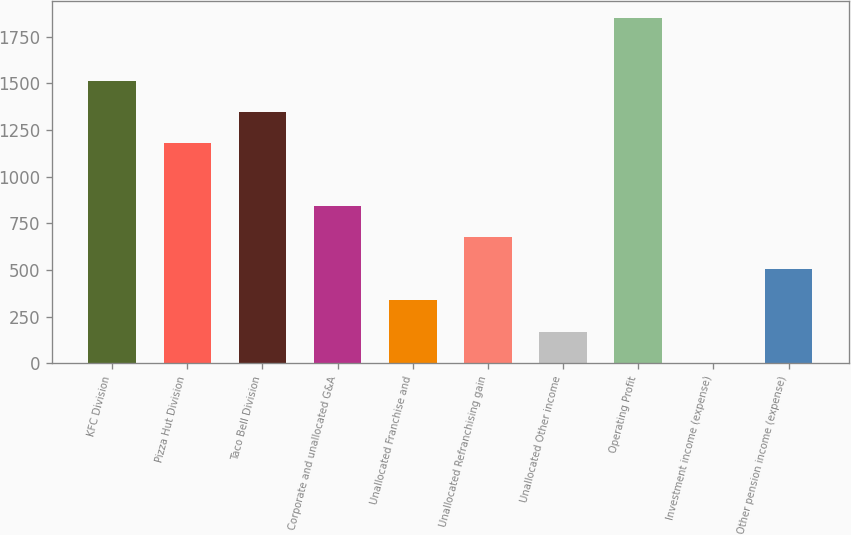Convert chart to OTSL. <chart><loc_0><loc_0><loc_500><loc_500><bar_chart><fcel>KFC Division<fcel>Pizza Hut Division<fcel>Taco Bell Division<fcel>Corporate and unallocated G&A<fcel>Unallocated Franchise and<fcel>Unallocated Refranchising gain<fcel>Unallocated Other income<fcel>Operating Profit<fcel>Investment income (expense)<fcel>Other pension income (expense)<nl><fcel>1514<fcel>1178<fcel>1346<fcel>842<fcel>338<fcel>674<fcel>170<fcel>1850<fcel>2<fcel>506<nl></chart> 